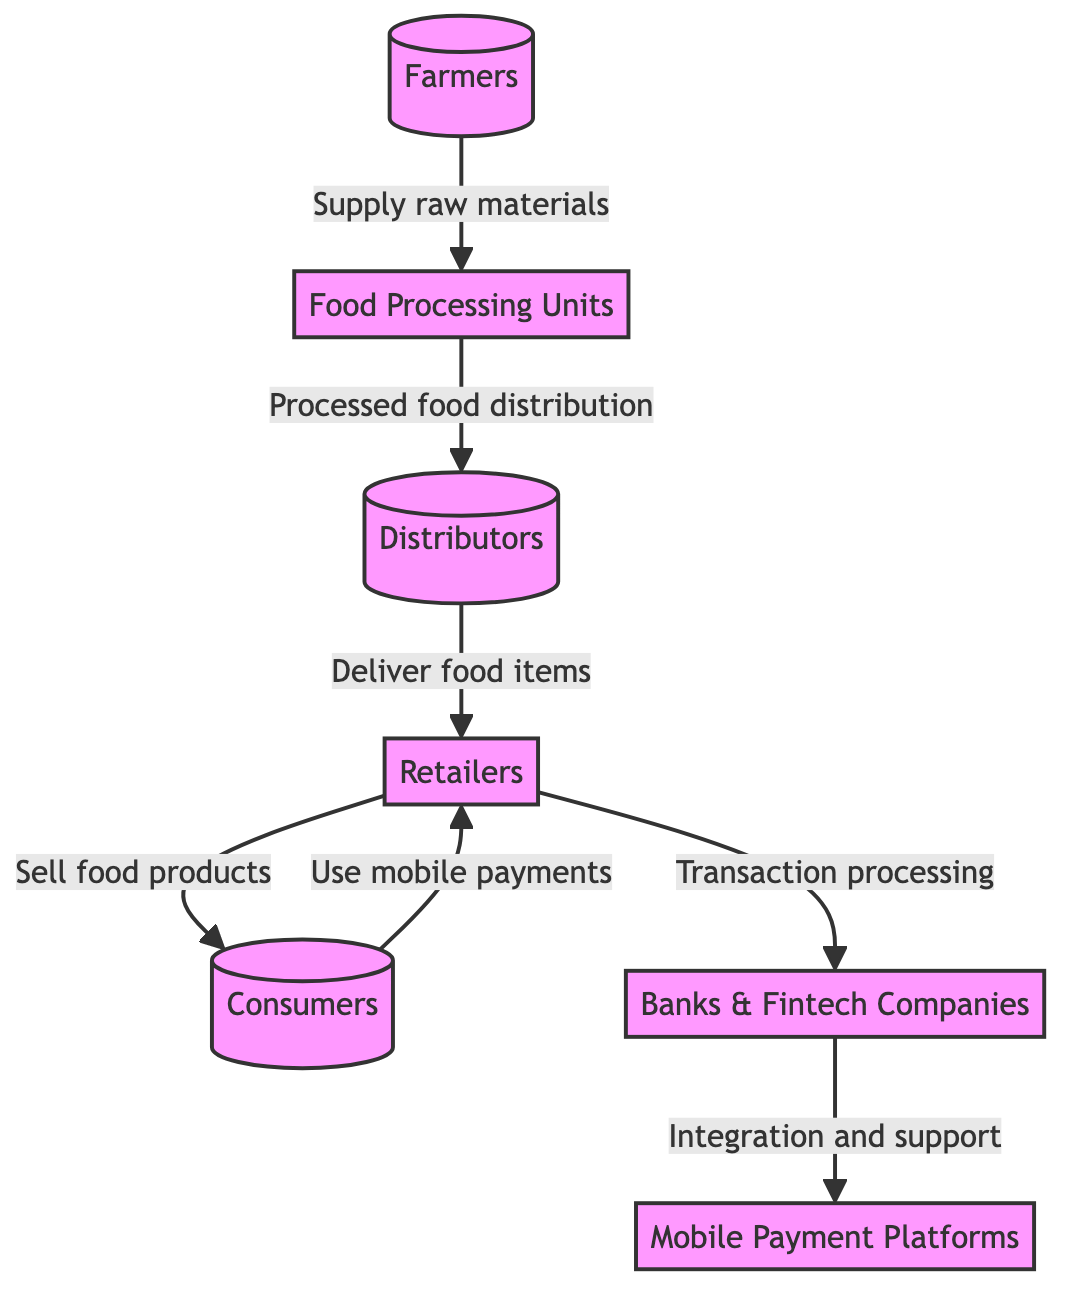What are the nodes involved in the food distribution network? The food distribution network in the diagram includes six nodes: Farmers, Food Processing Units, Distributors, Retailers, Consumers, and Mobile Payment Platforms.
Answer: Farmers, Food Processing Units, Distributors, Retailers, Consumers, Mobile Payment Platforms Which two entities are connected by the "Processed food distribution" relationship? In the diagram, the Food Processing Units and Distributors are connected by the "Processed food distribution" relationship as indicated by the arrow between them.
Answer: Food Processing Units and Distributors How many total nodes are present in the diagram? By counting the distinct entities represented in the diagram, we find that there are seven nodes in total: five primary players and two payment providers.
Answer: 7 What role do banks and fintech companies play in this network? Banks and fintech companies are depicted as providing integration and support to Mobile Payment Platforms, facilitating transactions in the food distribution process.
Answer: Integration and support Which group uses mobile payments primarily? Consumers are identified in the diagram as the group that uses mobile payments when engaging with retailers to purchase food products.
Answer: Consumers What type of platforms connect retailers and banks/fintech companies? The Mobile Payment Platforms serve as the connecting interface between retailers and banks or fintech companies, enabling transaction processing.
Answer: Mobile Payment Platforms What happens after food is delivered by distributors? Once food is delivered by distributors, it is sold by retailers to consumers, as shown by the direct connection that follows in the flow of the diagram.
Answer: Sold by retailers How many direct transactions are there in the flow from farmers to consumers? The flow consists of three direct transactions: from Farmers to Food Processing Units, from Food Processing Units to Distributors, and from Distributors to Retailers, followed by one more from Retailers to Consumers.
Answer: 4 What is the overall flow of goods from the starting point to the end consumer? The overall flow starts from Farmers supplying raw materials to Food Processing Units, which then sends processed food to Distributors; from there, it is delivered to Retailers, and finally sold to Consumers.
Answer: Farmers to Consumers 